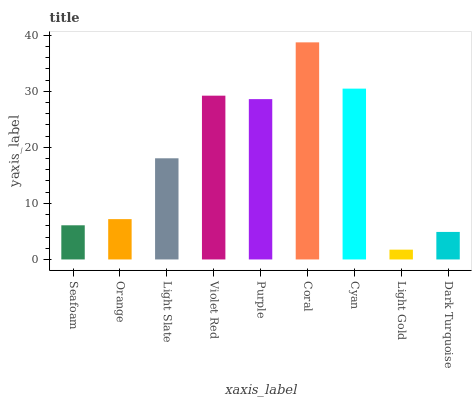Is Light Gold the minimum?
Answer yes or no. Yes. Is Coral the maximum?
Answer yes or no. Yes. Is Orange the minimum?
Answer yes or no. No. Is Orange the maximum?
Answer yes or no. No. Is Orange greater than Seafoam?
Answer yes or no. Yes. Is Seafoam less than Orange?
Answer yes or no. Yes. Is Seafoam greater than Orange?
Answer yes or no. No. Is Orange less than Seafoam?
Answer yes or no. No. Is Light Slate the high median?
Answer yes or no. Yes. Is Light Slate the low median?
Answer yes or no. Yes. Is Light Gold the high median?
Answer yes or no. No. Is Light Gold the low median?
Answer yes or no. No. 